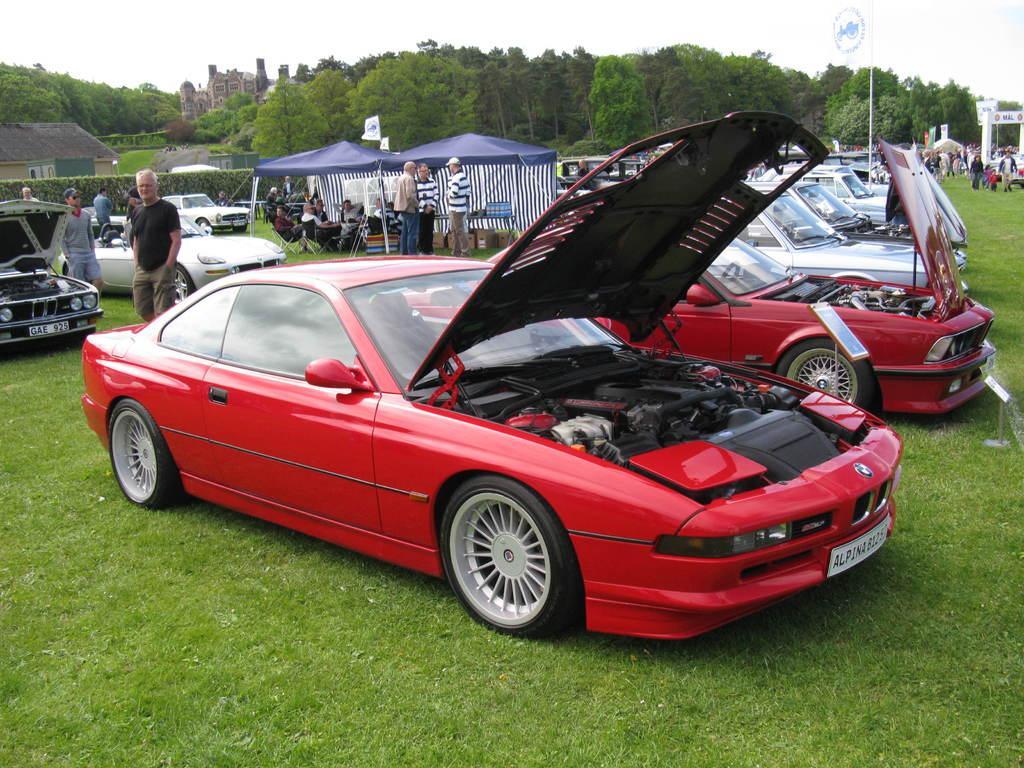Can you describe this image briefly? In this image there is a ground, on the ground there are few vehicles, persons, tents, under the tent there are few people, sitting on the chairs, trees, at the top there is the sky, on the left side there is a house, bushes, on the right side there are few people. 